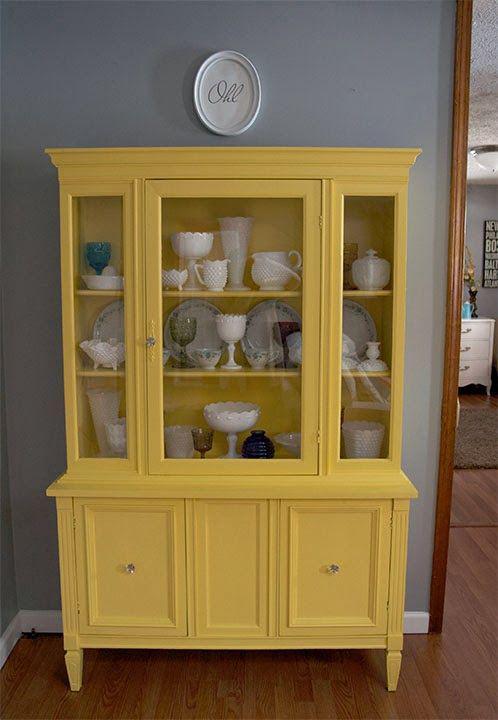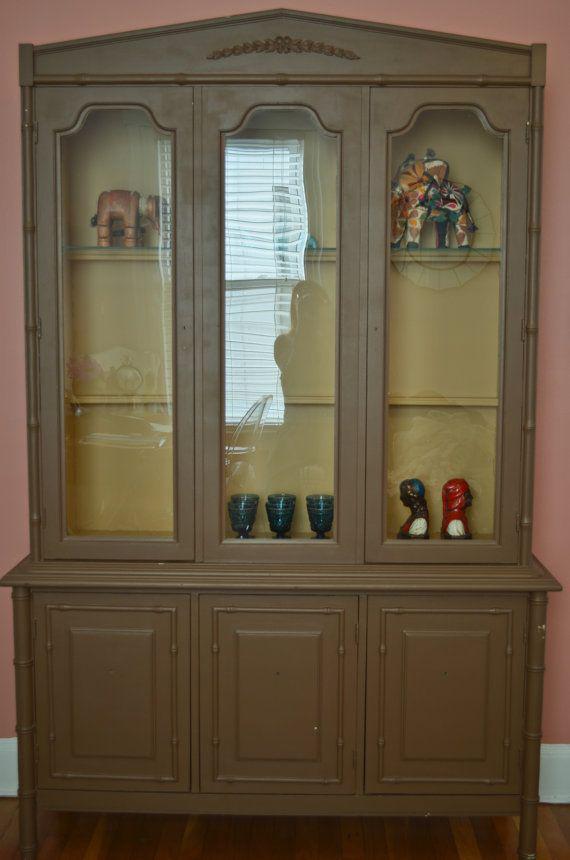The first image is the image on the left, the second image is the image on the right. Given the left and right images, does the statement "A flat-topped cabinet includes bright yellow on at least some surface." hold true? Answer yes or no. Yes. The first image is the image on the left, the second image is the image on the right. For the images displayed, is the sentence "At least one white furniture contain dishes." factually correct? Answer yes or no. No. 